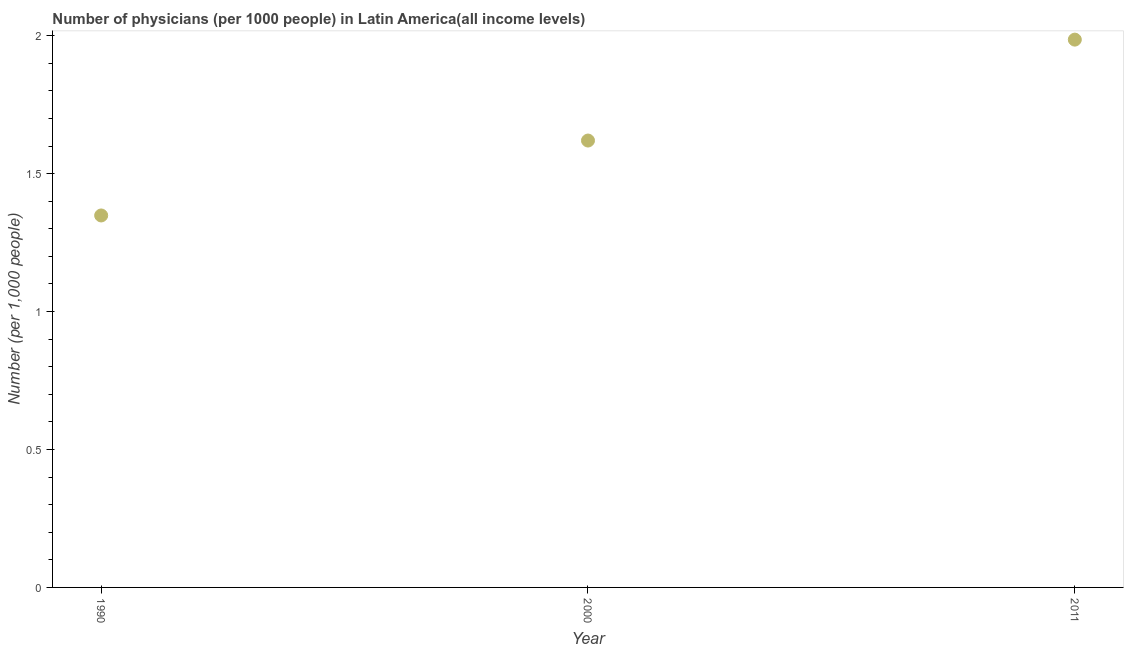What is the number of physicians in 2011?
Provide a short and direct response. 1.99. Across all years, what is the maximum number of physicians?
Give a very brief answer. 1.99. Across all years, what is the minimum number of physicians?
Your answer should be very brief. 1.35. What is the sum of the number of physicians?
Your answer should be compact. 4.95. What is the difference between the number of physicians in 1990 and 2011?
Make the answer very short. -0.64. What is the average number of physicians per year?
Give a very brief answer. 1.65. What is the median number of physicians?
Keep it short and to the point. 1.62. What is the ratio of the number of physicians in 2000 to that in 2011?
Provide a short and direct response. 0.82. Is the number of physicians in 2000 less than that in 2011?
Offer a terse response. Yes. What is the difference between the highest and the second highest number of physicians?
Provide a short and direct response. 0.37. Is the sum of the number of physicians in 2000 and 2011 greater than the maximum number of physicians across all years?
Ensure brevity in your answer.  Yes. What is the difference between the highest and the lowest number of physicians?
Provide a succinct answer. 0.64. How many dotlines are there?
Offer a terse response. 1. How many years are there in the graph?
Offer a very short reply. 3. Does the graph contain any zero values?
Provide a succinct answer. No. What is the title of the graph?
Ensure brevity in your answer.  Number of physicians (per 1000 people) in Latin America(all income levels). What is the label or title of the X-axis?
Your answer should be very brief. Year. What is the label or title of the Y-axis?
Make the answer very short. Number (per 1,0 people). What is the Number (per 1,000 people) in 1990?
Give a very brief answer. 1.35. What is the Number (per 1,000 people) in 2000?
Offer a very short reply. 1.62. What is the Number (per 1,000 people) in 2011?
Offer a very short reply. 1.99. What is the difference between the Number (per 1,000 people) in 1990 and 2000?
Keep it short and to the point. -0.27. What is the difference between the Number (per 1,000 people) in 1990 and 2011?
Give a very brief answer. -0.64. What is the difference between the Number (per 1,000 people) in 2000 and 2011?
Ensure brevity in your answer.  -0.37. What is the ratio of the Number (per 1,000 people) in 1990 to that in 2000?
Your answer should be very brief. 0.83. What is the ratio of the Number (per 1,000 people) in 1990 to that in 2011?
Offer a terse response. 0.68. What is the ratio of the Number (per 1,000 people) in 2000 to that in 2011?
Make the answer very short. 0.82. 